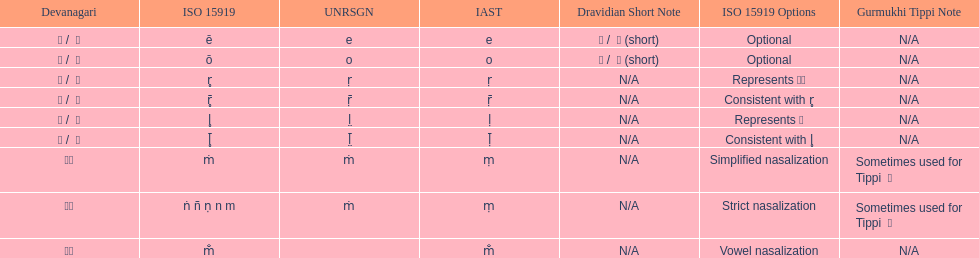What is the total number of translations? 8. 